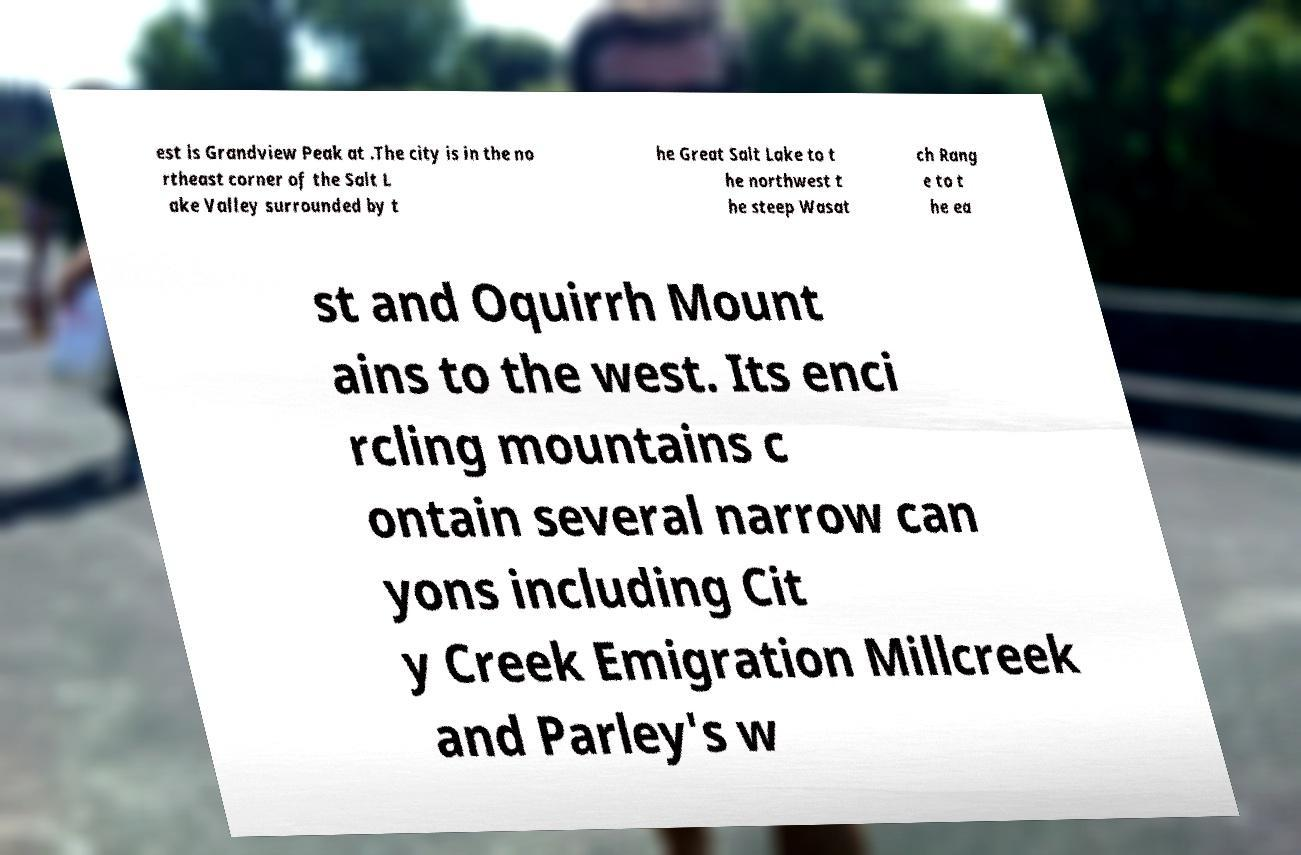Please read and relay the text visible in this image. What does it say? est is Grandview Peak at .The city is in the no rtheast corner of the Salt L ake Valley surrounded by t he Great Salt Lake to t he northwest t he steep Wasat ch Rang e to t he ea st and Oquirrh Mount ains to the west. Its enci rcling mountains c ontain several narrow can yons including Cit y Creek Emigration Millcreek and Parley's w 